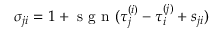<formula> <loc_0><loc_0><loc_500><loc_500>\sigma _ { j i } = 1 + s g n ( \tau _ { j } ^ { ( i ) } - \tau _ { i } ^ { ( j ) } + s _ { j i } )</formula> 